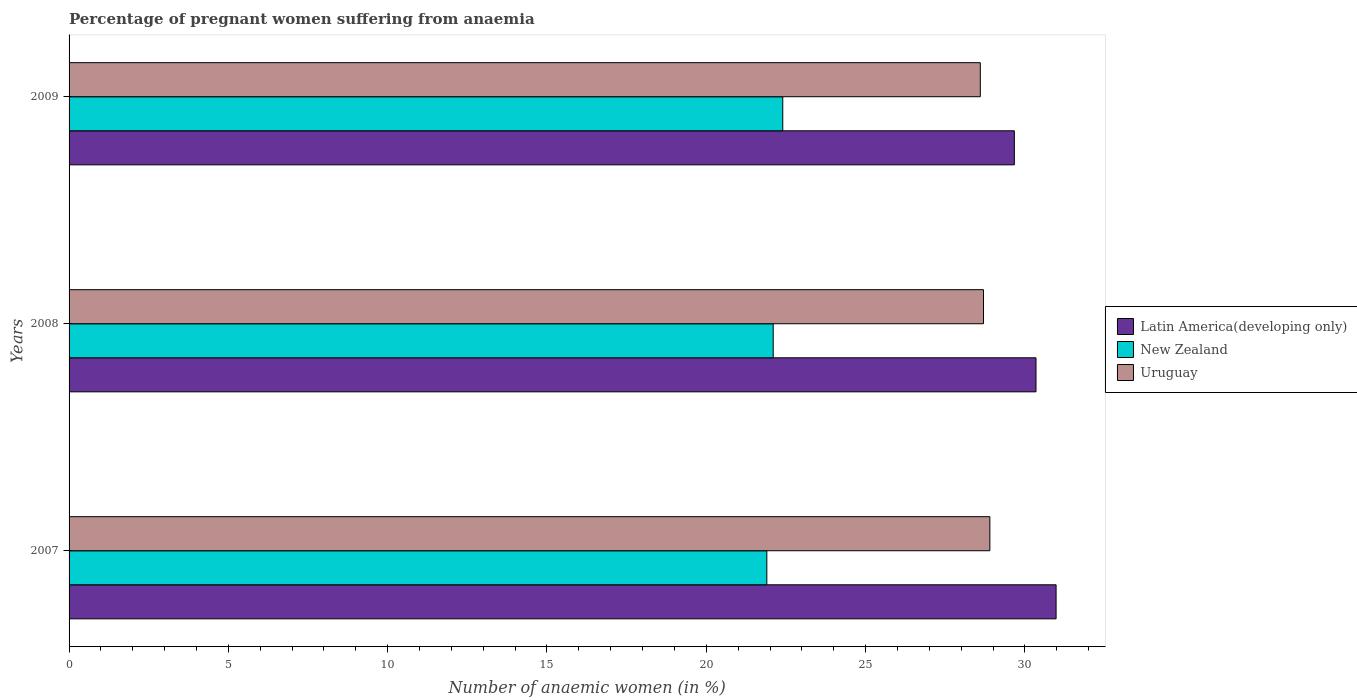How many groups of bars are there?
Offer a very short reply. 3. Are the number of bars per tick equal to the number of legend labels?
Keep it short and to the point. Yes. Are the number of bars on each tick of the Y-axis equal?
Offer a very short reply. Yes. How many bars are there on the 3rd tick from the top?
Make the answer very short. 3. How many bars are there on the 2nd tick from the bottom?
Your answer should be very brief. 3. What is the number of anaemic women in New Zealand in 2008?
Ensure brevity in your answer.  22.1. Across all years, what is the maximum number of anaemic women in Uruguay?
Your response must be concise. 28.9. Across all years, what is the minimum number of anaemic women in Latin America(developing only)?
Ensure brevity in your answer.  29.67. In which year was the number of anaemic women in New Zealand maximum?
Ensure brevity in your answer.  2009. What is the total number of anaemic women in New Zealand in the graph?
Offer a very short reply. 66.4. What is the difference between the number of anaemic women in Uruguay in 2007 and that in 2009?
Offer a terse response. 0.3. What is the difference between the number of anaemic women in New Zealand in 2009 and the number of anaemic women in Uruguay in 2008?
Make the answer very short. -6.3. What is the average number of anaemic women in New Zealand per year?
Your answer should be compact. 22.13. In the year 2008, what is the difference between the number of anaemic women in Latin America(developing only) and number of anaemic women in New Zealand?
Offer a terse response. 8.25. In how many years, is the number of anaemic women in Uruguay greater than 2 %?
Offer a terse response. 3. What is the ratio of the number of anaemic women in Latin America(developing only) in 2008 to that in 2009?
Offer a very short reply. 1.02. What is the difference between the highest and the second highest number of anaemic women in Uruguay?
Your answer should be very brief. 0.2. What is the difference between the highest and the lowest number of anaemic women in Uruguay?
Offer a very short reply. 0.3. Is the sum of the number of anaemic women in New Zealand in 2007 and 2009 greater than the maximum number of anaemic women in Uruguay across all years?
Ensure brevity in your answer.  Yes. What does the 1st bar from the top in 2007 represents?
Keep it short and to the point. Uruguay. What does the 1st bar from the bottom in 2007 represents?
Offer a very short reply. Latin America(developing only). Are all the bars in the graph horizontal?
Your response must be concise. Yes. How many years are there in the graph?
Ensure brevity in your answer.  3. What is the difference between two consecutive major ticks on the X-axis?
Keep it short and to the point. 5. Does the graph contain any zero values?
Your response must be concise. No. Where does the legend appear in the graph?
Your answer should be very brief. Center right. How many legend labels are there?
Your response must be concise. 3. How are the legend labels stacked?
Provide a short and direct response. Vertical. What is the title of the graph?
Your response must be concise. Percentage of pregnant women suffering from anaemia. What is the label or title of the X-axis?
Give a very brief answer. Number of anaemic women (in %). What is the label or title of the Y-axis?
Your answer should be compact. Years. What is the Number of anaemic women (in %) in Latin America(developing only) in 2007?
Your answer should be very brief. 30.98. What is the Number of anaemic women (in %) in New Zealand in 2007?
Your response must be concise. 21.9. What is the Number of anaemic women (in %) of Uruguay in 2007?
Provide a short and direct response. 28.9. What is the Number of anaemic women (in %) in Latin America(developing only) in 2008?
Your response must be concise. 30.35. What is the Number of anaemic women (in %) in New Zealand in 2008?
Your answer should be very brief. 22.1. What is the Number of anaemic women (in %) in Uruguay in 2008?
Your answer should be very brief. 28.7. What is the Number of anaemic women (in %) of Latin America(developing only) in 2009?
Give a very brief answer. 29.67. What is the Number of anaemic women (in %) of New Zealand in 2009?
Offer a very short reply. 22.4. What is the Number of anaemic women (in %) of Uruguay in 2009?
Keep it short and to the point. 28.6. Across all years, what is the maximum Number of anaemic women (in %) of Latin America(developing only)?
Give a very brief answer. 30.98. Across all years, what is the maximum Number of anaemic women (in %) in New Zealand?
Give a very brief answer. 22.4. Across all years, what is the maximum Number of anaemic women (in %) of Uruguay?
Your response must be concise. 28.9. Across all years, what is the minimum Number of anaemic women (in %) of Latin America(developing only)?
Offer a very short reply. 29.67. Across all years, what is the minimum Number of anaemic women (in %) of New Zealand?
Offer a terse response. 21.9. Across all years, what is the minimum Number of anaemic women (in %) of Uruguay?
Your answer should be compact. 28.6. What is the total Number of anaemic women (in %) of Latin America(developing only) in the graph?
Your answer should be compact. 91. What is the total Number of anaemic women (in %) of New Zealand in the graph?
Offer a terse response. 66.4. What is the total Number of anaemic women (in %) in Uruguay in the graph?
Give a very brief answer. 86.2. What is the difference between the Number of anaemic women (in %) in Latin America(developing only) in 2007 and that in 2008?
Your answer should be very brief. 0.63. What is the difference between the Number of anaemic women (in %) of New Zealand in 2007 and that in 2008?
Your answer should be compact. -0.2. What is the difference between the Number of anaemic women (in %) of Latin America(developing only) in 2007 and that in 2009?
Your answer should be compact. 1.31. What is the difference between the Number of anaemic women (in %) of Latin America(developing only) in 2008 and that in 2009?
Provide a succinct answer. 0.68. What is the difference between the Number of anaemic women (in %) of Latin America(developing only) in 2007 and the Number of anaemic women (in %) of New Zealand in 2008?
Make the answer very short. 8.88. What is the difference between the Number of anaemic women (in %) in Latin America(developing only) in 2007 and the Number of anaemic women (in %) in Uruguay in 2008?
Keep it short and to the point. 2.28. What is the difference between the Number of anaemic women (in %) of New Zealand in 2007 and the Number of anaemic women (in %) of Uruguay in 2008?
Offer a terse response. -6.8. What is the difference between the Number of anaemic women (in %) of Latin America(developing only) in 2007 and the Number of anaemic women (in %) of New Zealand in 2009?
Give a very brief answer. 8.58. What is the difference between the Number of anaemic women (in %) in Latin America(developing only) in 2007 and the Number of anaemic women (in %) in Uruguay in 2009?
Keep it short and to the point. 2.38. What is the difference between the Number of anaemic women (in %) in New Zealand in 2007 and the Number of anaemic women (in %) in Uruguay in 2009?
Offer a very short reply. -6.7. What is the difference between the Number of anaemic women (in %) of Latin America(developing only) in 2008 and the Number of anaemic women (in %) of New Zealand in 2009?
Offer a terse response. 7.95. What is the difference between the Number of anaemic women (in %) in Latin America(developing only) in 2008 and the Number of anaemic women (in %) in Uruguay in 2009?
Give a very brief answer. 1.75. What is the difference between the Number of anaemic women (in %) in New Zealand in 2008 and the Number of anaemic women (in %) in Uruguay in 2009?
Make the answer very short. -6.5. What is the average Number of anaemic women (in %) in Latin America(developing only) per year?
Your response must be concise. 30.33. What is the average Number of anaemic women (in %) of New Zealand per year?
Offer a very short reply. 22.13. What is the average Number of anaemic women (in %) in Uruguay per year?
Offer a very short reply. 28.73. In the year 2007, what is the difference between the Number of anaemic women (in %) in Latin America(developing only) and Number of anaemic women (in %) in New Zealand?
Your answer should be very brief. 9.08. In the year 2007, what is the difference between the Number of anaemic women (in %) in Latin America(developing only) and Number of anaemic women (in %) in Uruguay?
Offer a very short reply. 2.08. In the year 2007, what is the difference between the Number of anaemic women (in %) of New Zealand and Number of anaemic women (in %) of Uruguay?
Give a very brief answer. -7. In the year 2008, what is the difference between the Number of anaemic women (in %) in Latin America(developing only) and Number of anaemic women (in %) in New Zealand?
Ensure brevity in your answer.  8.25. In the year 2008, what is the difference between the Number of anaemic women (in %) in Latin America(developing only) and Number of anaemic women (in %) in Uruguay?
Keep it short and to the point. 1.65. In the year 2009, what is the difference between the Number of anaemic women (in %) of Latin America(developing only) and Number of anaemic women (in %) of New Zealand?
Make the answer very short. 7.27. In the year 2009, what is the difference between the Number of anaemic women (in %) of Latin America(developing only) and Number of anaemic women (in %) of Uruguay?
Make the answer very short. 1.07. In the year 2009, what is the difference between the Number of anaemic women (in %) of New Zealand and Number of anaemic women (in %) of Uruguay?
Make the answer very short. -6.2. What is the ratio of the Number of anaemic women (in %) of Latin America(developing only) in 2007 to that in 2008?
Offer a terse response. 1.02. What is the ratio of the Number of anaemic women (in %) in New Zealand in 2007 to that in 2008?
Keep it short and to the point. 0.99. What is the ratio of the Number of anaemic women (in %) in Latin America(developing only) in 2007 to that in 2009?
Offer a very short reply. 1.04. What is the ratio of the Number of anaemic women (in %) of New Zealand in 2007 to that in 2009?
Your response must be concise. 0.98. What is the ratio of the Number of anaemic women (in %) in Uruguay in 2007 to that in 2009?
Your answer should be very brief. 1.01. What is the ratio of the Number of anaemic women (in %) of Latin America(developing only) in 2008 to that in 2009?
Keep it short and to the point. 1.02. What is the ratio of the Number of anaemic women (in %) in New Zealand in 2008 to that in 2009?
Your answer should be compact. 0.99. What is the difference between the highest and the second highest Number of anaemic women (in %) in Latin America(developing only)?
Your response must be concise. 0.63. What is the difference between the highest and the lowest Number of anaemic women (in %) in Latin America(developing only)?
Keep it short and to the point. 1.31. 